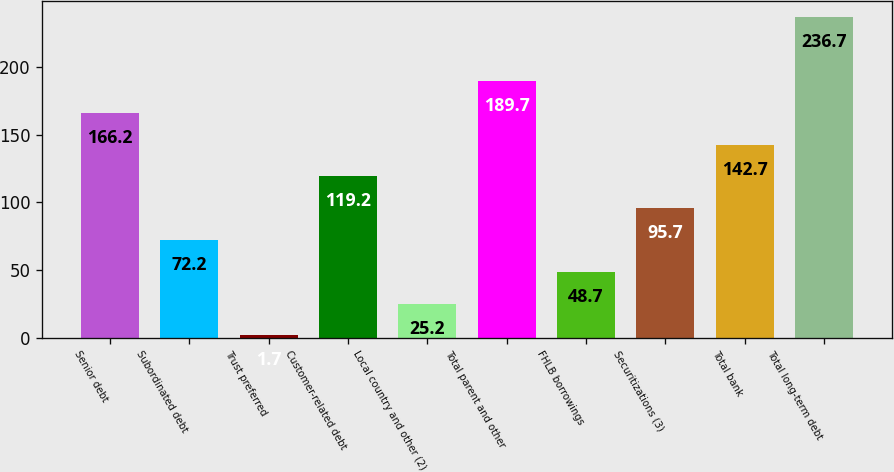Convert chart. <chart><loc_0><loc_0><loc_500><loc_500><bar_chart><fcel>Senior debt<fcel>Subordinated debt<fcel>Trust preferred<fcel>Customer-related debt<fcel>Local country and other (2)<fcel>Total parent and other<fcel>FHLB borrowings<fcel>Securitizations (3)<fcel>Total bank<fcel>Total long-term debt<nl><fcel>166.2<fcel>72.2<fcel>1.7<fcel>119.2<fcel>25.2<fcel>189.7<fcel>48.7<fcel>95.7<fcel>142.7<fcel>236.7<nl></chart> 